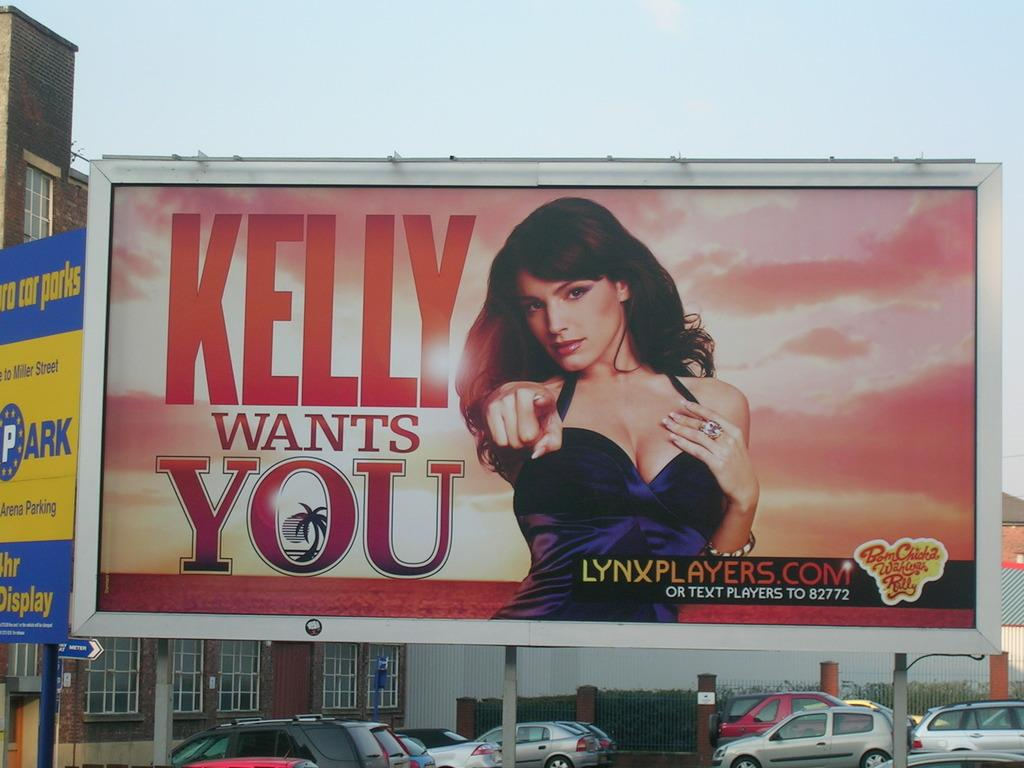Provide a one-sentence caption for the provided image. Kelly Wants you banner with a lynxplayers.com website on the bottom right. 